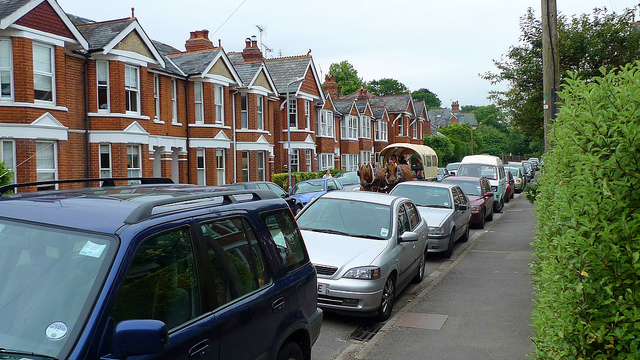Identify and read out the text in this image. E 